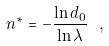Convert formula to latex. <formula><loc_0><loc_0><loc_500><loc_500>n ^ { \ast } = - \frac { \ln d _ { 0 } } { \ln \lambda } \ ,</formula> 